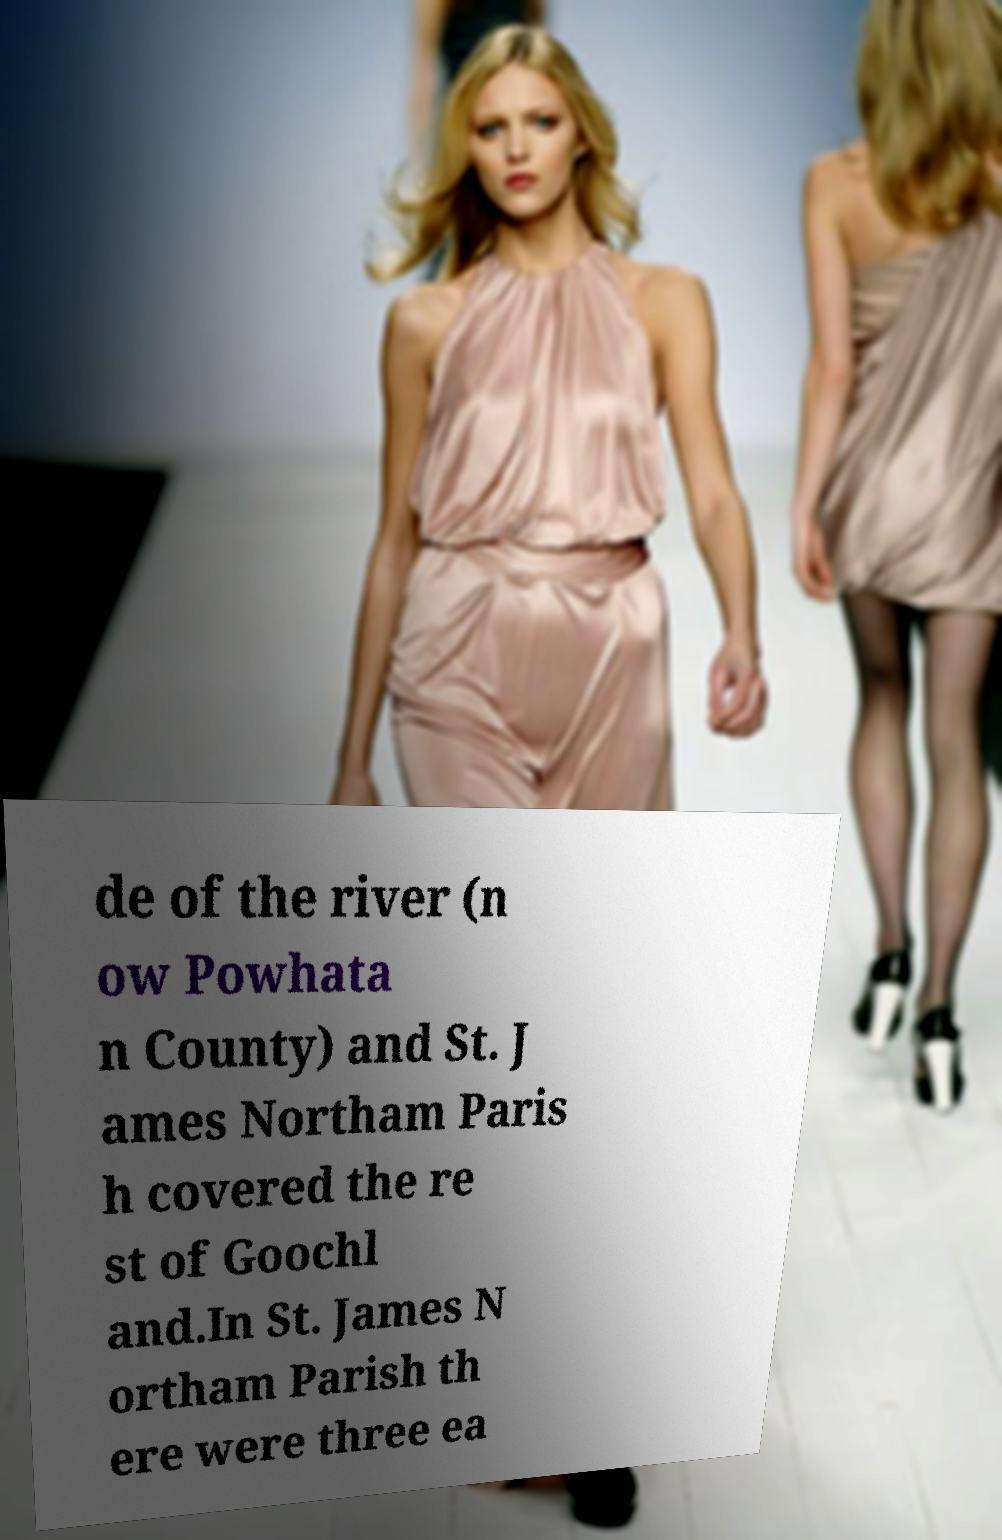Please identify and transcribe the text found in this image. de of the river (n ow Powhata n County) and St. J ames Northam Paris h covered the re st of Goochl and.In St. James N ortham Parish th ere were three ea 